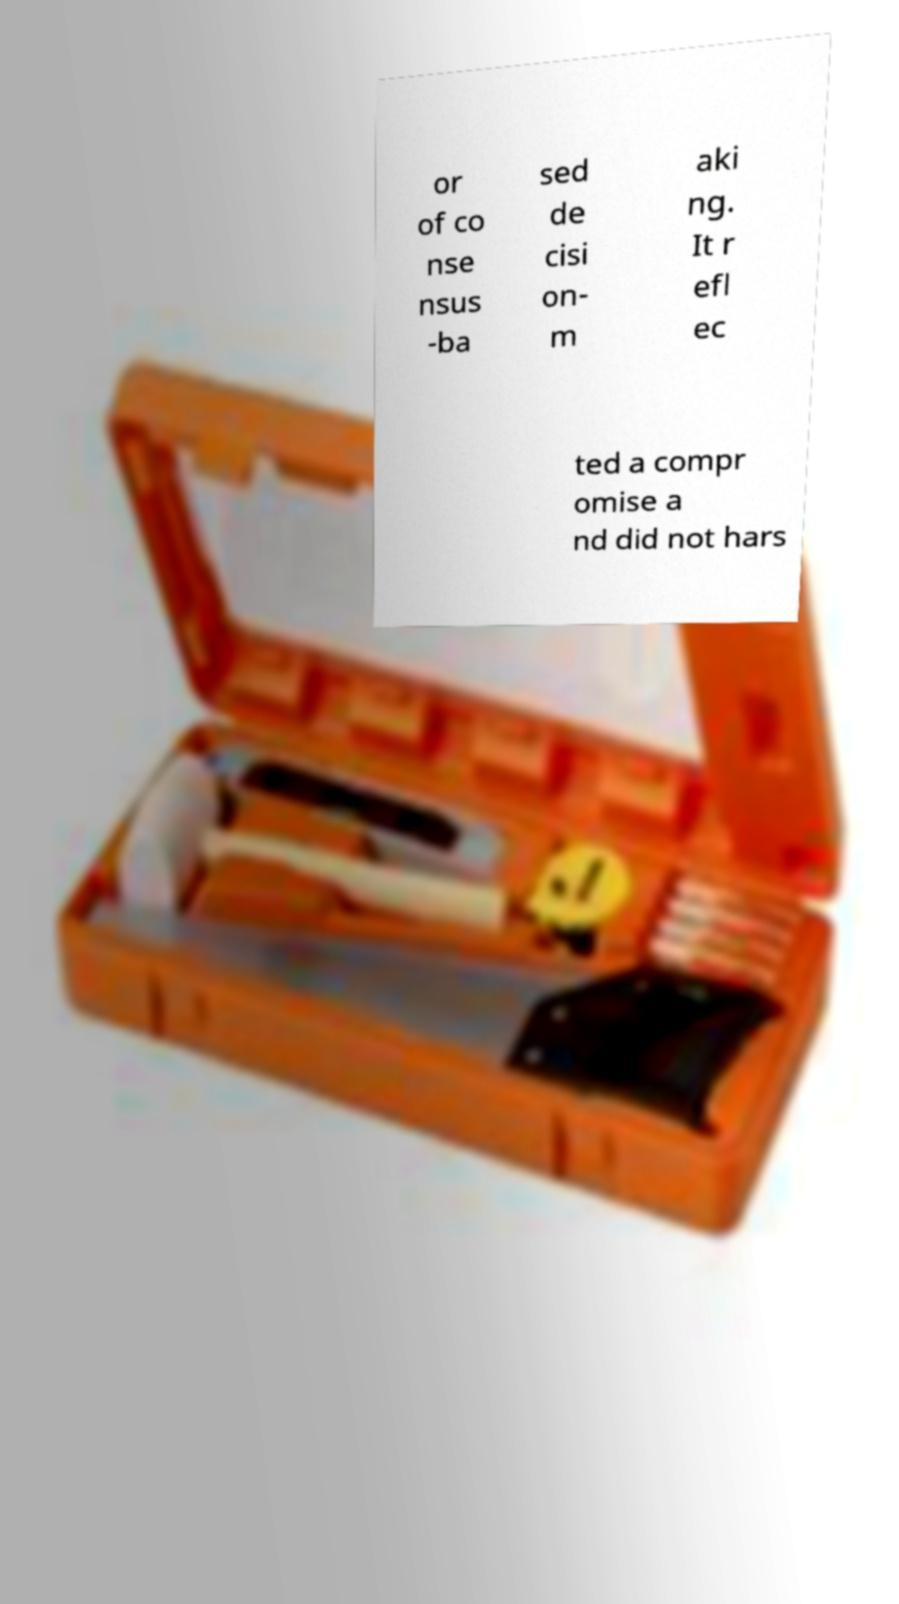Can you read and provide the text displayed in the image?This photo seems to have some interesting text. Can you extract and type it out for me? or of co nse nsus -ba sed de cisi on- m aki ng. It r efl ec ted a compr omise a nd did not hars 